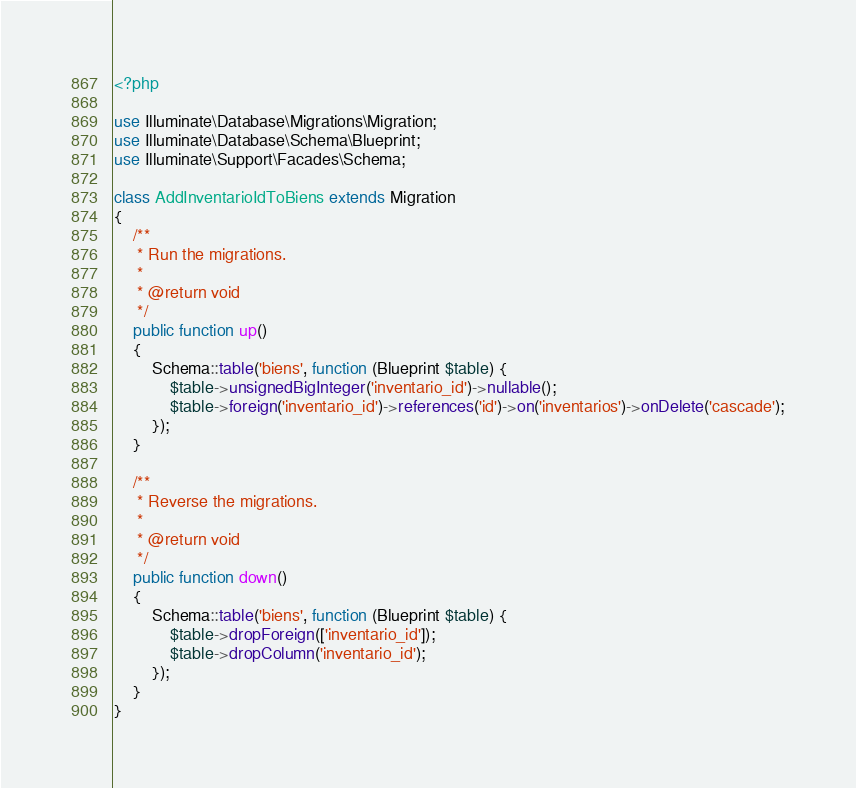<code> <loc_0><loc_0><loc_500><loc_500><_PHP_><?php

use Illuminate\Database\Migrations\Migration;
use Illuminate\Database\Schema\Blueprint;
use Illuminate\Support\Facades\Schema;

class AddInventarioIdToBiens extends Migration
{
    /**
     * Run the migrations.
     *
     * @return void
     */
    public function up()
    {
        Schema::table('biens', function (Blueprint $table) {
            $table->unsignedBigInteger('inventario_id')->nullable();
            $table->foreign('inventario_id')->references('id')->on('inventarios')->onDelete('cascade');
        });
    }

    /**
     * Reverse the migrations.
     *
     * @return void
     */
    public function down()
    {
        Schema::table('biens', function (Blueprint $table) {
            $table->dropForeign(['inventario_id']);
            $table->dropColumn('inventario_id');
        });
    }
}
</code> 